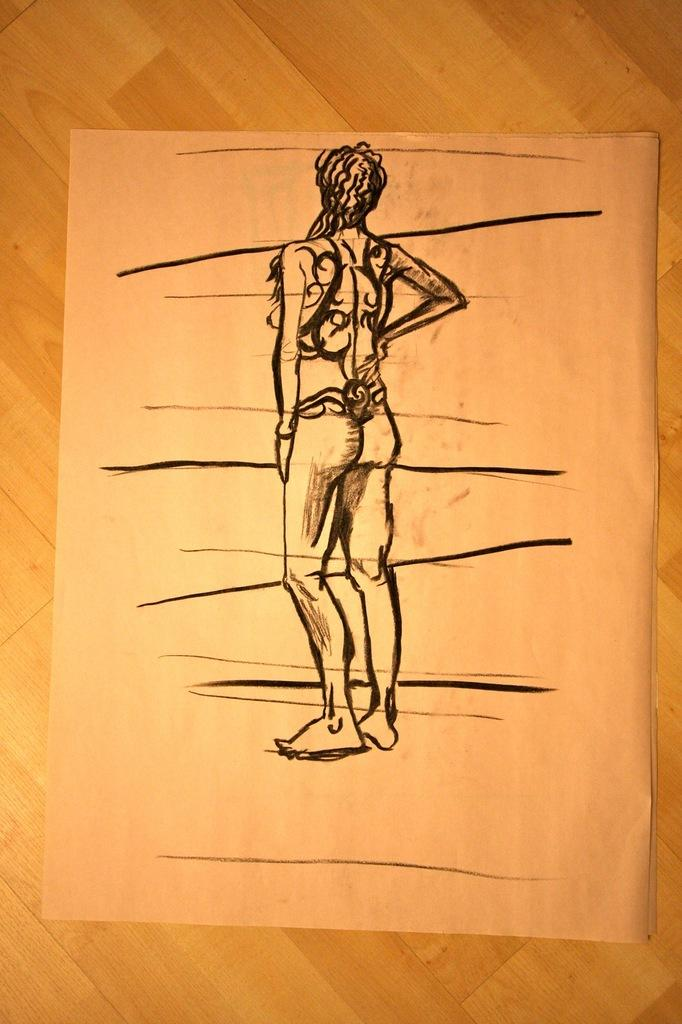What is depicted in the image? There is a sketch of a person in the image. What is the medium of the sketch? The sketch is on a paper. What type of calculator is being used by the person in the sketch? There is no calculator present in the image, as it only features a sketch of a person on a paper. 